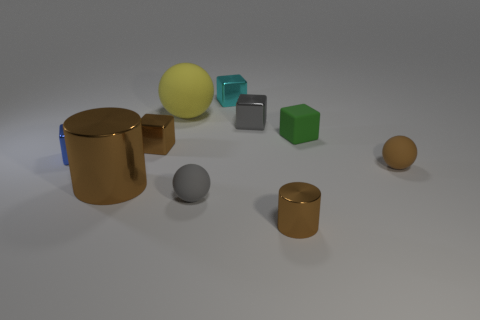The rubber thing that is the same color as the large cylinder is what shape?
Your answer should be compact. Sphere. What is the material of the block that is on the left side of the small cyan metal cube and right of the blue object?
Your response must be concise. Metal. What size is the ball that is the same color as the large shiny object?
Offer a very short reply. Small. What is the tiny ball right of the rubber ball that is in front of the big brown thing made of?
Your response must be concise. Rubber. What size is the sphere in front of the tiny brown object on the right side of the tiny metallic object in front of the tiny blue shiny object?
Offer a terse response. Small. What number of green cubes have the same material as the brown sphere?
Ensure brevity in your answer.  1. The cylinder that is to the right of the shiny block that is behind the gray shiny thing is what color?
Provide a short and direct response. Brown. What number of things are large brown rubber balls or small metallic things that are in front of the yellow thing?
Your answer should be very brief. 4. Are there any metallic things that have the same color as the big sphere?
Ensure brevity in your answer.  No. How many brown things are small balls or small metal cylinders?
Give a very brief answer. 2. 